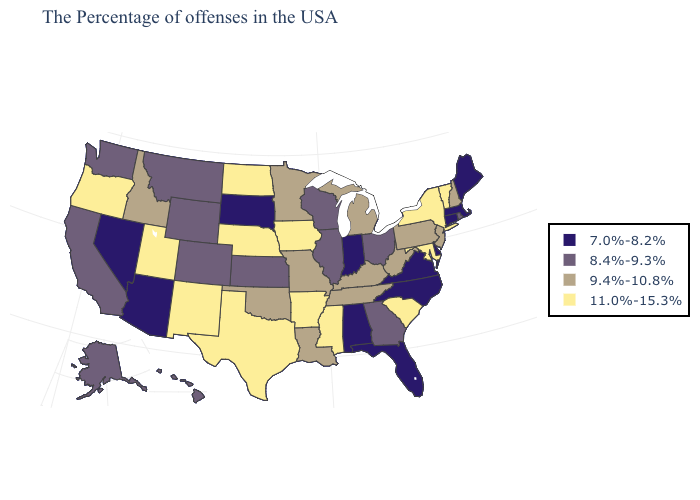What is the value of New Jersey?
Keep it brief. 9.4%-10.8%. Does the map have missing data?
Keep it brief. No. What is the value of Mississippi?
Be succinct. 11.0%-15.3%. Does North Carolina have the lowest value in the USA?
Short answer required. Yes. Name the states that have a value in the range 8.4%-9.3%?
Short answer required. Rhode Island, Ohio, Georgia, Wisconsin, Illinois, Kansas, Wyoming, Colorado, Montana, California, Washington, Alaska, Hawaii. Name the states that have a value in the range 8.4%-9.3%?
Write a very short answer. Rhode Island, Ohio, Georgia, Wisconsin, Illinois, Kansas, Wyoming, Colorado, Montana, California, Washington, Alaska, Hawaii. What is the value of Delaware?
Write a very short answer. 7.0%-8.2%. Among the states that border Pennsylvania , does New York have the highest value?
Quick response, please. Yes. Does the first symbol in the legend represent the smallest category?
Write a very short answer. Yes. Does the first symbol in the legend represent the smallest category?
Short answer required. Yes. Name the states that have a value in the range 11.0%-15.3%?
Concise answer only. Vermont, New York, Maryland, South Carolina, Mississippi, Arkansas, Iowa, Nebraska, Texas, North Dakota, New Mexico, Utah, Oregon. Name the states that have a value in the range 11.0%-15.3%?
Keep it brief. Vermont, New York, Maryland, South Carolina, Mississippi, Arkansas, Iowa, Nebraska, Texas, North Dakota, New Mexico, Utah, Oregon. Which states have the highest value in the USA?
Short answer required. Vermont, New York, Maryland, South Carolina, Mississippi, Arkansas, Iowa, Nebraska, Texas, North Dakota, New Mexico, Utah, Oregon. Which states have the highest value in the USA?
Give a very brief answer. Vermont, New York, Maryland, South Carolina, Mississippi, Arkansas, Iowa, Nebraska, Texas, North Dakota, New Mexico, Utah, Oregon. Does Michigan have the lowest value in the MidWest?
Answer briefly. No. 